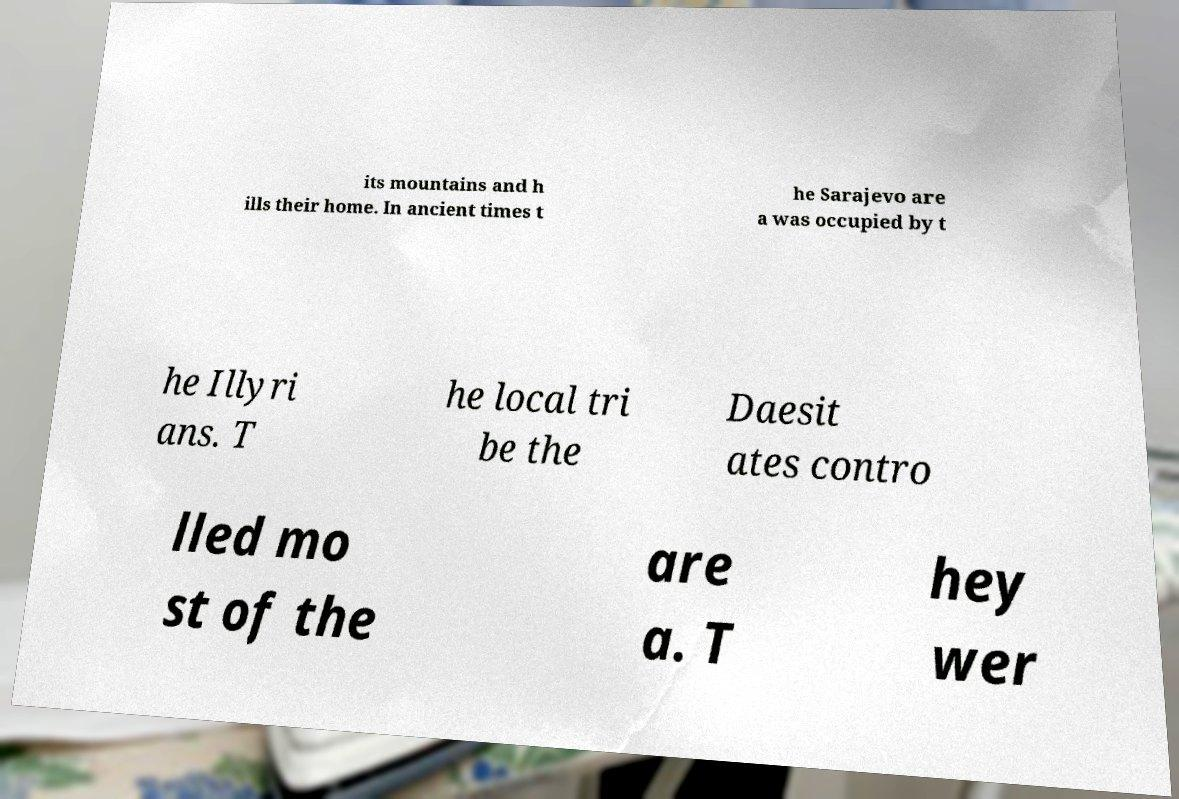For documentation purposes, I need the text within this image transcribed. Could you provide that? its mountains and h ills their home. In ancient times t he Sarajevo are a was occupied by t he Illyri ans. T he local tri be the Daesit ates contro lled mo st of the are a. T hey wer 